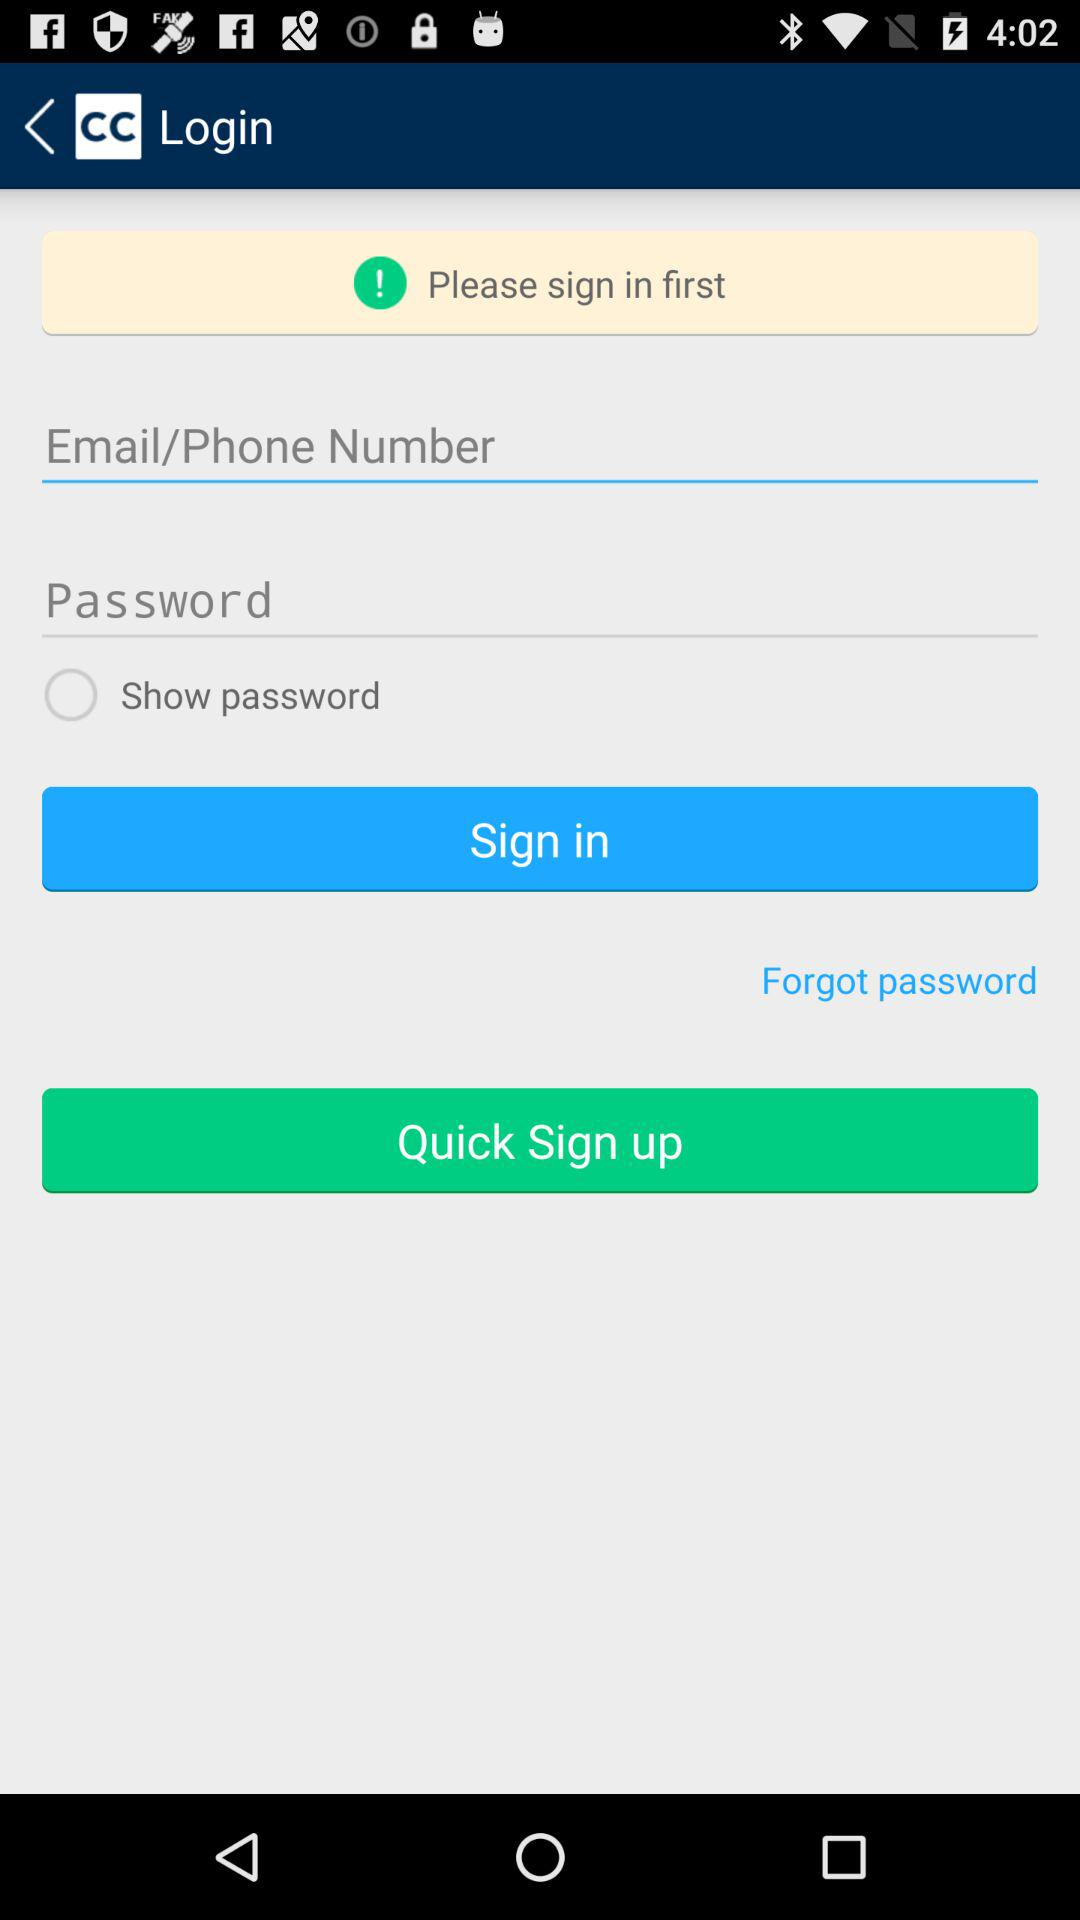How many text inputs are on the screen?
Answer the question using a single word or phrase. 2 